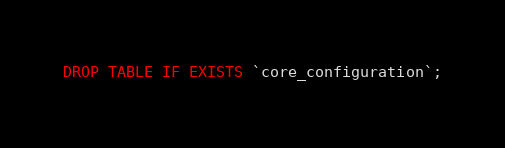<code> <loc_0><loc_0><loc_500><loc_500><_SQL_>DROP TABLE IF EXISTS `core_configuration`;
</code> 